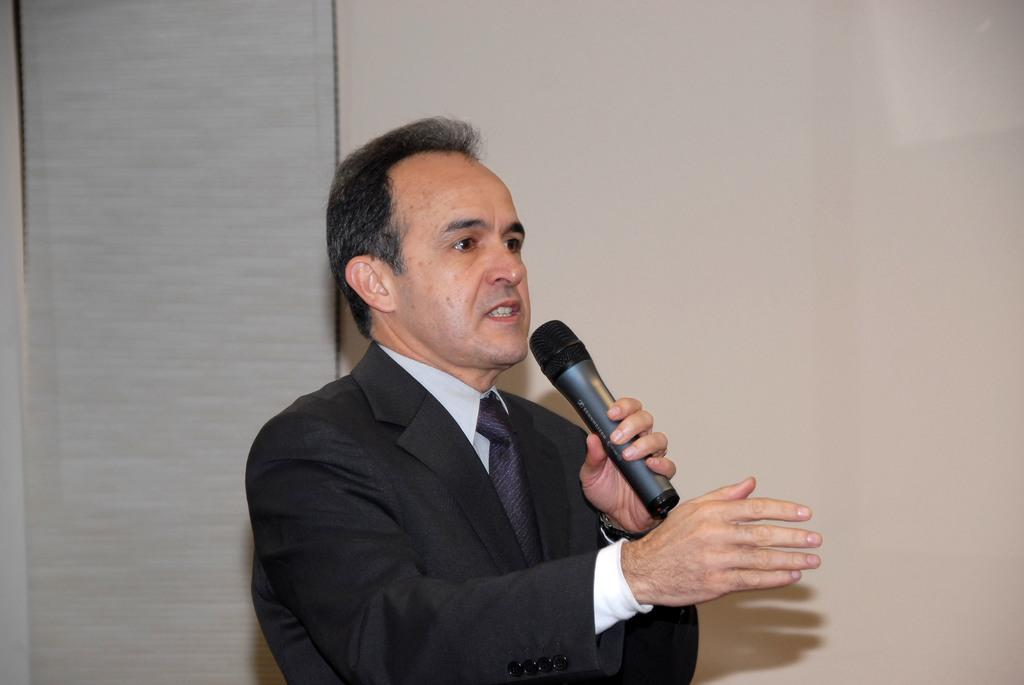Who is the main subject in the image? There is a man in the image. What is the man wearing? The man is wearing a black coat. What is the man holding in his left hand? The man is holding a microphone in his left hand. What is the man doing in the image? The man is speaking. What can be seen in the background of the image? There is a cream-colored wall in the background of the image. How many kittens are sitting on the tray in the image? There is no tray or kittens present in the image. 